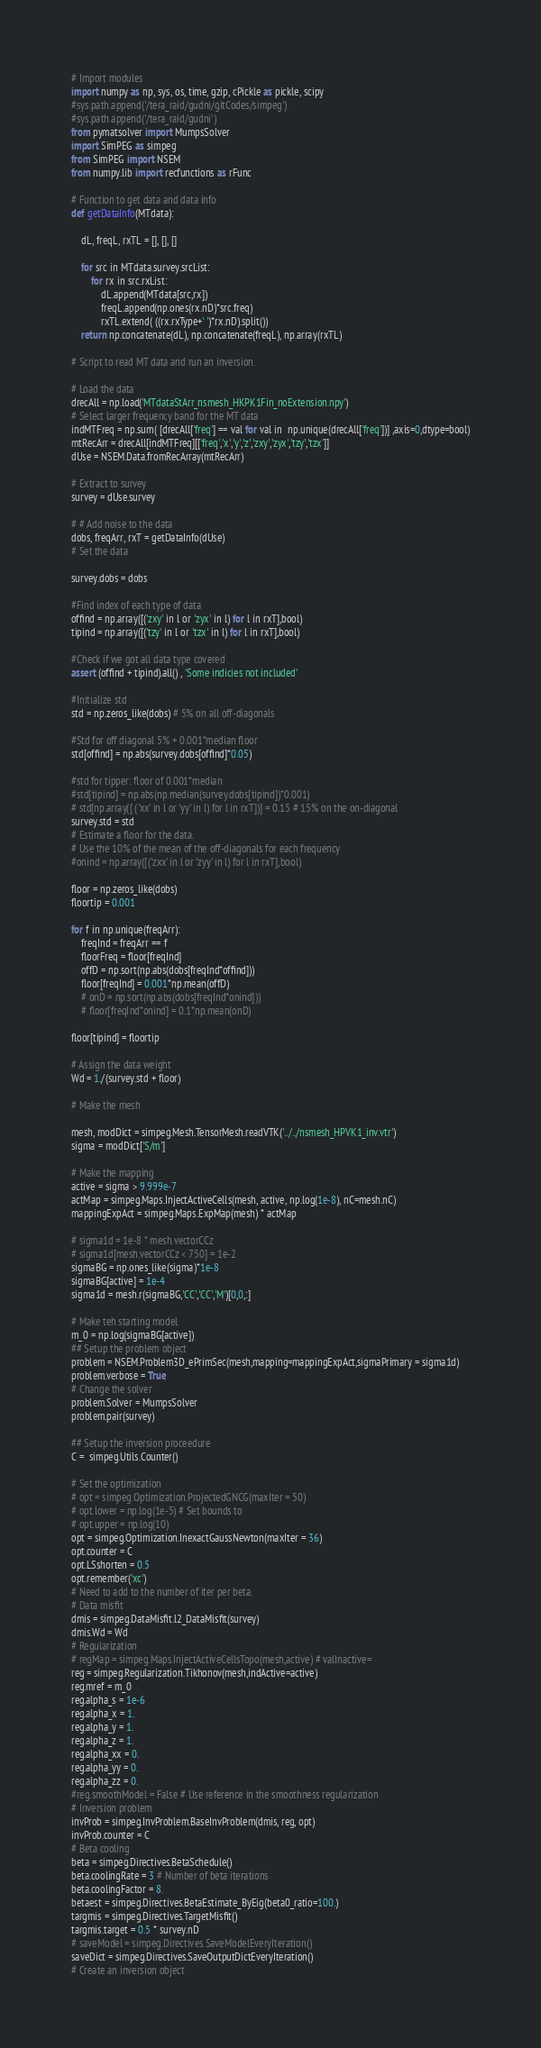Convert code to text. <code><loc_0><loc_0><loc_500><loc_500><_Python_># Import modules
import numpy as np, sys, os, time, gzip, cPickle as pickle, scipy
#sys.path.append('/tera_raid/gudni/gitCodes/simpeg')
#sys.path.append('/tera_raid/gudni')
from pymatsolver import MumpsSolver
import SimPEG as simpeg
from SimPEG import NSEM
from numpy.lib import recfunctions as rFunc

# Function to get data and data info
def getDataInfo(MTdata):

    dL, freqL, rxTL = [], [], []

    for src in MTdata.survey.srcList:
        for rx in src.rxList:
            dL.append(MTdata[src,rx])
            freqL.append(np.ones(rx.nD)*src.freq)
            rxTL.extend( ((rx.rxType+' ')*rx.nD).split())
    return np.concatenate(dL), np.concatenate(freqL), np.array(rxTL)

# Script to read MT data and run an inversion.

# Load the data
drecAll = np.load('MTdataStArr_nsmesh_HKPK1Fin_noExtension.npy')
# Select larger frequency band for the MT data
indMTFreq = np.sum( [drecAll['freq'] == val for val in  np.unique(drecAll['freq'])] ,axis=0,dtype=bool)
mtRecArr = drecAll[indMTFreq][['freq','x','y','z','zxy','zyx','tzy','tzx']]
dUse = NSEM.Data.fromRecArray(mtRecArr)

# Extract to survey
survey = dUse.survey

# # Add noise to the data
dobs, freqArr, rxT = getDataInfo(dUse)
# Set the data

survey.dobs = dobs

#Find index of each type of data
offind = np.array([('zxy' in l or 'zyx' in l) for l in rxT],bool)
tipind = np.array([('tzy' in l or 'tzx' in l) for l in rxT],bool)

#Check if we got all data type covered
assert (offind + tipind).all() , 'Some indicies not included'

#Initialize std
std = np.zeros_like(dobs) # 5% on all off-diagonals

#Std for off diagonal 5% + 0.001*median floor
std[offind] = np.abs(survey.dobs[offind]*0.05)

#std for tipper: floor of 0.001*median
#std[tipind] = np.abs(np.median(survey.dobs[tipind])*0.001)
# std[np.array([ ('xx' in l or 'yy' in l) for l in rxT])] = 0.15 # 15% on the on-diagonal
survey.std = std 
# Estimate a floor for the data.
# Use the 10% of the mean of the off-diagonals for each frequency
#onind = np.array([('zxx' in l or 'zyy' in l) for l in rxT],bool)

floor = np.zeros_like(dobs)
floortip = 0.001

for f in np.unique(freqArr):
    freqInd = freqArr == f
    floorFreq = floor[freqInd]
    offD = np.sort(np.abs(dobs[freqInd*offind]))
    floor[freqInd] = 0.001*np.mean(offD)
    # onD = np.sort(np.abs(dobs[freqInd*onind]))
    # floor[freqInd*onind] = 0.1*np.mean(onD)

floor[tipind] = floortip

# Assign the data weight
Wd = 1./(survey.std + floor)

# Make the mesh

mesh, modDict = simpeg.Mesh.TensorMesh.readVTK('../../nsmesh_HPVK1_inv.vtr')
sigma = modDict['S/m']

# Make the mapping
active = sigma > 9.999e-7
actMap = simpeg.Maps.InjectActiveCells(mesh, active, np.log(1e-8), nC=mesh.nC)  
mappingExpAct = simpeg.Maps.ExpMap(mesh) * actMap

# sigma1d = 1e-8 * mesh.vectorCCz
# sigma1d[mesh.vectorCCz < 750] = 1e-2
sigmaBG = np.ones_like(sigma)*1e-8
sigmaBG[active] = 1e-4
sigma1d = mesh.r(sigmaBG,'CC','CC','M')[0,0,:]

# Make teh starting model
m_0 = np.log(sigmaBG[active])
## Setup the problem object
problem = NSEM.Problem3D_ePrimSec(mesh,mapping=mappingExpAct,sigmaPrimary = sigma1d)
problem.verbose = True
# Change the solver
problem.Solver = MumpsSolver
problem.pair(survey)

## Setup the inversion proceedure
C =  simpeg.Utils.Counter()

# Set the optimization
# opt = simpeg.Optimization.ProjectedGNCG(maxIter = 50)
# opt.lower = np.log(1e-5) # Set bounds to
# opt.upper = np.log(10)
opt = simpeg.Optimization.InexactGaussNewton(maxIter = 36)
opt.counter = C
opt.LSshorten = 0.5
opt.remember('xc')
# Need to add to the number of iter per beta.
# Data misfit
dmis = simpeg.DataMisfit.l2_DataMisfit(survey)
dmis.Wd = Wd
# Regularization
# regMap = simpeg.Maps.InjectActiveCellsTopo(mesh,active) # valInactive=
reg = simpeg.Regularization.Tikhonov(mesh,indActive=active)
reg.mref = m_0
reg.alpha_s = 1e-6
reg.alpha_x = 1.
reg.alpha_y = 1.
reg.alpha_z = 1.
reg.alpha_xx = 0.
reg.alpha_yy = 0.
reg.alpha_zz = 0.
#reg.smoothModel = False # Use reference in the smoothness regularization
# Inversion problem
invProb = simpeg.InvProblem.BaseInvProblem(dmis, reg, opt)
invProb.counter = C
# Beta cooling
beta = simpeg.Directives.BetaSchedule()
beta.coolingRate = 3 # Number of beta iterations
beta.coolingFactor = 8.
betaest = simpeg.Directives.BetaEstimate_ByEig(beta0_ratio=100.)
targmis = simpeg.Directives.TargetMisfit()
targmis.target = 0.5 * survey.nD
# saveModel = simpeg.Directives.SaveModelEveryIteration()
saveDict = simpeg.Directives.SaveOutputDictEveryIteration()
# Create an inversion object</code> 